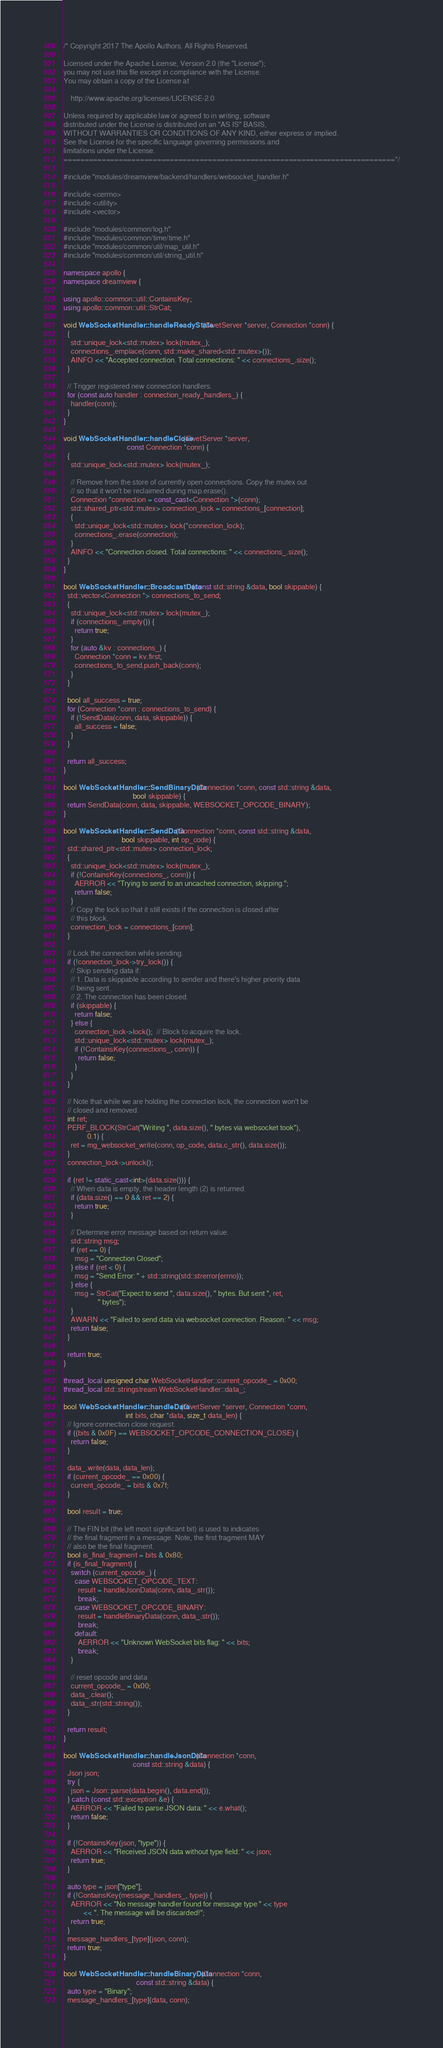<code> <loc_0><loc_0><loc_500><loc_500><_C++_>/* Copyright 2017 The Apollo Authors. All Rights Reserved.

Licensed under the Apache License, Version 2.0 (the "License");
you may not use this file except in compliance with the License.
You may obtain a copy of the License at

    http://www.apache.org/licenses/LICENSE-2.0

Unless required by applicable law or agreed to in writing, software
distributed under the License is distributed on an "AS IS" BASIS,
WITHOUT WARRANTIES OR CONDITIONS OF ANY KIND, either express or implied.
See the License for the specific language governing permissions and
limitations under the License.
==============================================================================*/

#include "modules/dreamview/backend/handlers/websocket_handler.h"

#include <cerrno>
#include <utility>
#include <vector>

#include "modules/common/log.h"
#include "modules/common/time/time.h"
#include "modules/common/util/map_util.h"
#include "modules/common/util/string_util.h"

namespace apollo {
namespace dreamview {

using apollo::common::util::ContainsKey;
using apollo::common::util::StrCat;

void WebSocketHandler::handleReadyState(CivetServer *server, Connection *conn) {
  {
    std::unique_lock<std::mutex> lock(mutex_);
    connections_.emplace(conn, std::make_shared<std::mutex>());
    AINFO << "Accepted connection. Total connections: " << connections_.size();
  }

  // Trigger registered new connection handlers.
  for (const auto handler : connection_ready_handlers_) {
    handler(conn);
  }
}

void WebSocketHandler::handleClose(CivetServer *server,
                                   const Connection *conn) {
  {
    std::unique_lock<std::mutex> lock(mutex_);

    // Remove from the store of currently open connections. Copy the mutex out
    // so that it won't be reclaimed during map.erase().
    Connection *connection = const_cast<Connection *>(conn);
    std::shared_ptr<std::mutex> connection_lock = connections_[connection];
    {
      std::unique_lock<std::mutex> lock(*connection_lock);
      connections_.erase(connection);
    }
    AINFO << "Connection closed. Total connections: " << connections_.size();
  }
}

bool WebSocketHandler::BroadcastData(const std::string &data, bool skippable) {
  std::vector<Connection *> connections_to_send;
  {
    std::unique_lock<std::mutex> lock(mutex_);
    if (connections_.empty()) {
      return true;
    }
    for (auto &kv : connections_) {
      Connection *conn = kv.first;
      connections_to_send.push_back(conn);
    }
  }

  bool all_success = true;
  for (Connection *conn : connections_to_send) {
    if (!SendData(conn, data, skippable)) {
      all_success = false;
    }
  }

  return all_success;
}

bool WebSocketHandler::SendBinaryData(Connection *conn, const std::string &data,
                                      bool skippable) {
  return SendData(conn, data, skippable, WEBSOCKET_OPCODE_BINARY);
}

bool WebSocketHandler::SendData(Connection *conn, const std::string &data,
                                bool skippable, int op_code) {
  std::shared_ptr<std::mutex> connection_lock;
  {
    std::unique_lock<std::mutex> lock(mutex_);
    if (!ContainsKey(connections_, conn)) {
      AERROR << "Trying to send to an uncached connection, skipping.";
      return false;
    }
    // Copy the lock so that it still exists if the connection is closed after
    // this block.
    connection_lock = connections_[conn];
  }

  // Lock the connection while sending.
  if (!connection_lock->try_lock()) {
    // Skip sending data if:
    // 1. Data is skippable according to sender and there's higher priority data
    // being sent.
    // 2. The connection has been closed.
    if (skippable) {
      return false;
    } else {
      connection_lock->lock();  // Block to acquire the lock.
      std::unique_lock<std::mutex> lock(mutex_);
      if (!ContainsKey(connections_, conn)) {
        return false;
      }
    }
  }

  // Note that while we are holding the connection lock, the connection won't be
  // closed and removed.
  int ret;
  PERF_BLOCK(StrCat("Writing ", data.size(), " bytes via websocket took"),
             0.1) {
    ret = mg_websocket_write(conn, op_code, data.c_str(), data.size());
  }
  connection_lock->unlock();

  if (ret != static_cast<int>(data.size())) {
    // When data is empty, the header length (2) is returned.
    if (data.size() == 0 && ret == 2) {
      return true;
    }

    // Determine error message based on return value.
    std::string msg;
    if (ret == 0) {
      msg = "Connection Closed";
    } else if (ret < 0) {
      msg = "Send Error: " + std::string(std::strerror(errno));
    } else {
      msg = StrCat("Expect to send ", data.size(), " bytes. But sent ", ret,
                   " bytes");
    }
    AWARN << "Failed to send data via websocket connection. Reason: " << msg;
    return false;
  }

  return true;
}

thread_local unsigned char WebSocketHandler::current_opcode_ = 0x00;
thread_local std::stringstream WebSocketHandler::data_;

bool WebSocketHandler::handleData(CivetServer *server, Connection *conn,
                                  int bits, char *data, size_t data_len) {
  // Ignore connection close request.
  if ((bits & 0x0F) == WEBSOCKET_OPCODE_CONNECTION_CLOSE) {
    return false;
  }

  data_.write(data, data_len);
  if (current_opcode_ == 0x00) {
    current_opcode_ = bits & 0x7f;
  }

  bool result = true;

  // The FIN bit (the left most significant bit) is used to indicates
  // the final fragment in a message. Note, the first fragment MAY
  // also be the final fragment.
  bool is_final_fragment = bits & 0x80;
  if (is_final_fragment) {
    switch (current_opcode_) {
      case WEBSOCKET_OPCODE_TEXT:
        result = handleJsonData(conn, data_.str());
        break;
      case WEBSOCKET_OPCODE_BINARY:
        result = handleBinaryData(conn, data_.str());
        break;
      default:
        AERROR << "Unknown WebSocket bits flag: " << bits;
        break;
    }

    // reset opcode and data
    current_opcode_ = 0x00;
    data_.clear();
    data_.str(std::string());
  }

  return result;
}

bool WebSocketHandler::handleJsonData(Connection *conn,
                                      const std::string &data) {
  Json json;
  try {
    json = Json::parse(data.begin(), data.end());
  } catch (const std::exception &e) {
    AERROR << "Failed to parse JSON data: " << e.what();
    return false;
  }

  if (!ContainsKey(json, "type")) {
    AERROR << "Received JSON data without type field: " << json;
    return true;
  }

  auto type = json["type"];
  if (!ContainsKey(message_handlers_, type)) {
    AERROR << "No message handler found for message type " << type
           << ". The message will be discarded!";
    return true;
  }
  message_handlers_[type](json, conn);
  return true;
}

bool WebSocketHandler::handleBinaryData(Connection *conn,
                                        const std::string &data) {
  auto type = "Binary";
  message_handlers_[type](data, conn);</code> 